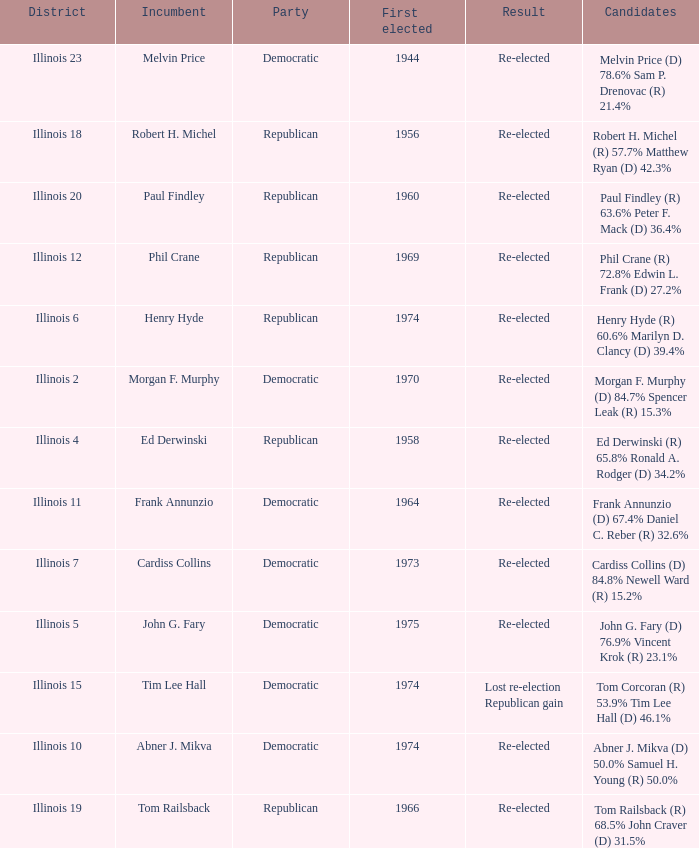Name the candidates for illinois 15 Tom Corcoran (R) 53.9% Tim Lee Hall (D) 46.1%. 